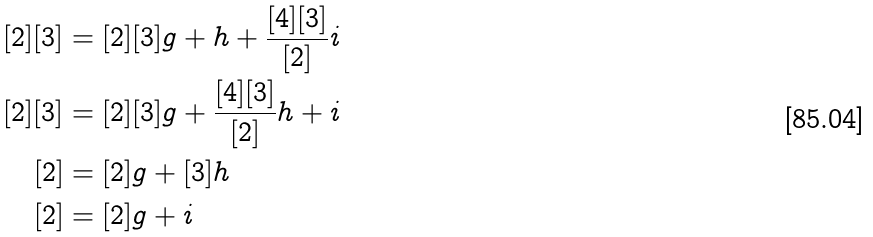Convert formula to latex. <formula><loc_0><loc_0><loc_500><loc_500>[ 2 ] [ 3 ] & = [ 2 ] [ 3 ] g + h + \frac { [ 4 ] [ 3 ] } { [ 2 ] } i \\ [ 2 ] [ 3 ] & = [ 2 ] [ 3 ] g + \frac { [ 4 ] [ 3 ] } { [ 2 ] } h + i \\ [ 2 ] & = [ 2 ] g + [ 3 ] h \\ [ 2 ] & = [ 2 ] g + i</formula> 